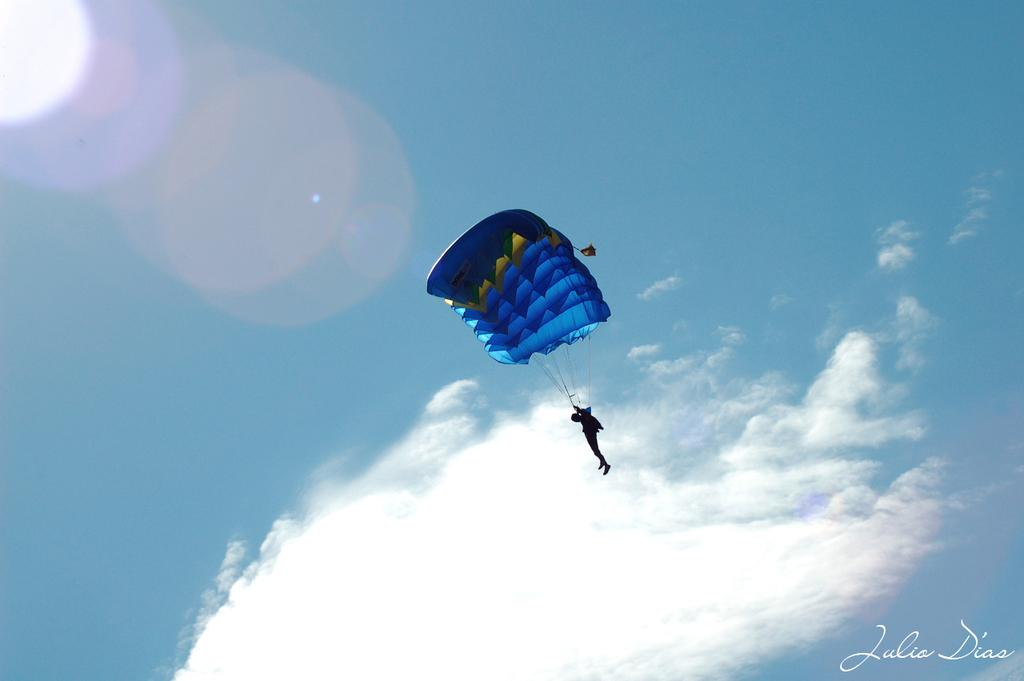What is the main subject of the image? There is a person in the image. What activity is the person engaged in? The person is doing para riding. What can be seen in the background of the image? The sky is visible in the background of the image. How would you describe the weather based on the image? The sky is sunny, which suggests good weather. How many roses can be seen in the image? There are no roses present in the image. What impulse might the person have experienced before engaging in para riding? The image does not provide any information about the person's emotions or impulses before engaging in para riding. 